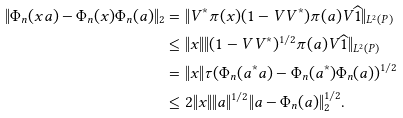<formula> <loc_0><loc_0><loc_500><loc_500>\| \Phi _ { n } ( x a ) - \Phi _ { n } ( x ) \Phi _ { n } ( a ) \| _ { 2 } & = \| V ^ { * } \pi ( x ) ( 1 - V V ^ { * } ) \pi ( a ) V \widehat { 1 } \| _ { L ^ { 2 } ( P ) } \\ & \leq \| x \| \| ( 1 - V V ^ { * } ) ^ { 1 / 2 } \pi ( a ) V \widehat { 1 } \| _ { L ^ { 2 } ( P ) } \\ & = \| x \| \tau ( \Phi _ { n } ( a ^ { * } a ) - \Phi _ { n } ( a ^ { * } ) \Phi _ { n } ( a ) ) ^ { 1 / 2 } \\ & \leq 2 \| x \| \| a \| ^ { 1 / 2 } \| a - \Phi _ { n } ( a ) \| _ { 2 } ^ { 1 / 2 } .</formula> 